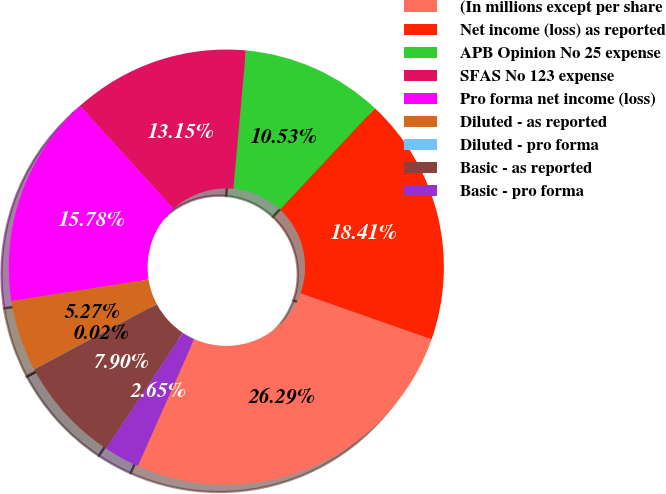Convert chart to OTSL. <chart><loc_0><loc_0><loc_500><loc_500><pie_chart><fcel>(In millions except per share<fcel>Net income (loss) as reported<fcel>APB Opinion No 25 expense<fcel>SFAS No 123 expense<fcel>Pro forma net income (loss)<fcel>Diluted - as reported<fcel>Diluted - pro forma<fcel>Basic - as reported<fcel>Basic - pro forma<nl><fcel>26.29%<fcel>18.41%<fcel>10.53%<fcel>13.15%<fcel>15.78%<fcel>5.27%<fcel>0.02%<fcel>7.9%<fcel>2.65%<nl></chart> 